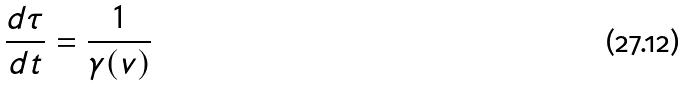Convert formula to latex. <formula><loc_0><loc_0><loc_500><loc_500>\frac { d \tau } { d t } = \frac { 1 } { \gamma ( v ) }</formula> 